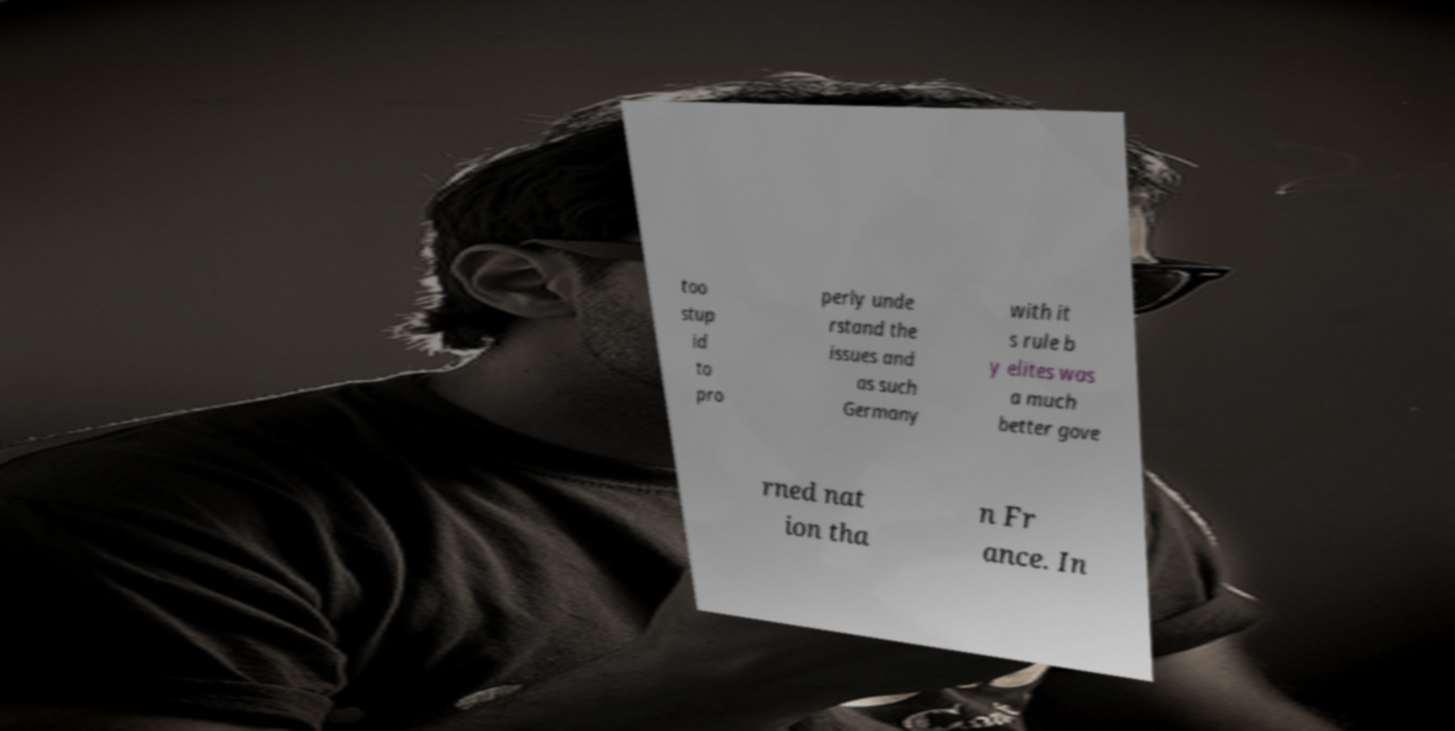For documentation purposes, I need the text within this image transcribed. Could you provide that? too stup id to pro perly unde rstand the issues and as such Germany with it s rule b y elites was a much better gove rned nat ion tha n Fr ance. In 